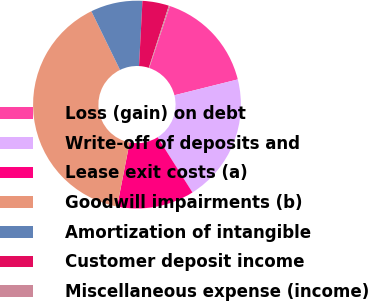<chart> <loc_0><loc_0><loc_500><loc_500><pie_chart><fcel>Loss (gain) on debt<fcel>Write-off of deposits and<fcel>Lease exit costs (a)<fcel>Goodwill impairments (b)<fcel>Amortization of intangible<fcel>Customer deposit income<fcel>Miscellaneous expense (income)<nl><fcel>15.98%<fcel>19.93%<fcel>12.03%<fcel>39.7%<fcel>8.07%<fcel>4.12%<fcel>0.17%<nl></chart> 